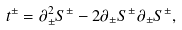Convert formula to latex. <formula><loc_0><loc_0><loc_500><loc_500>t ^ { \pm } = \partial _ { \pm } ^ { 2 } S ^ { \pm } - 2 \partial _ { \pm } S ^ { \pm } \partial _ { \pm } S ^ { \pm } ,</formula> 